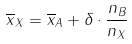<formula> <loc_0><loc_0><loc_500><loc_500>\overline { x } _ { X } = \overline { x } _ { A } + \delta \cdot \frac { n _ { B } } { n _ { X } }</formula> 